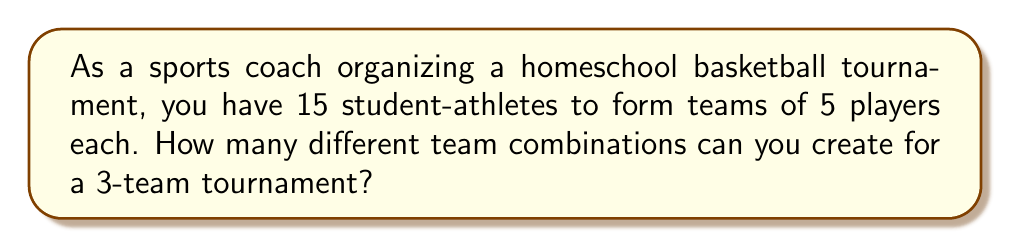Teach me how to tackle this problem. Let's approach this step-by-step:

1) This is a combination problem. We need to choose 3 teams of 5 players each from a pool of 15 players.

2) We can solve this using the following formula:

   $$\frac{15!}{(5!)^3 \cdot 3!}$$

3) Here's why:
   - We choose 5 players for the first team: $\binom{15}{5}$
   - Then 5 from the remaining 10 for the second team: $\binom{10}{5}$
   - Finally, 5 from the remaining 5 for the third team: $\binom{5}{5}$

4) Multiply these together: $\binom{15}{5} \cdot \binom{10}{5} \cdot \binom{5}{5}$

5) This can be written as:
   $$\frac{15!}{5!(15-5)!} \cdot \frac{10!}{5!(10-5)!} \cdot \frac{5!}{5!(5-5)!}$$

6) Simplify:
   $$\frac{15!}{5!10!} \cdot \frac{10!}{5!5!} \cdot \frac{5!}{5!0!}$$

7) This reduces to:
   $$\frac{15!}{(5!)^3}$$

8) However, the order of selecting the teams doesn't matter, so we divide by 3! to account for this:

   $$\frac{15!}{(5!)^3 \cdot 3!}$$

9) Calculate:
   $$\frac{15!}{(5!)^3 \cdot 3!} = 756$$
Answer: 756 